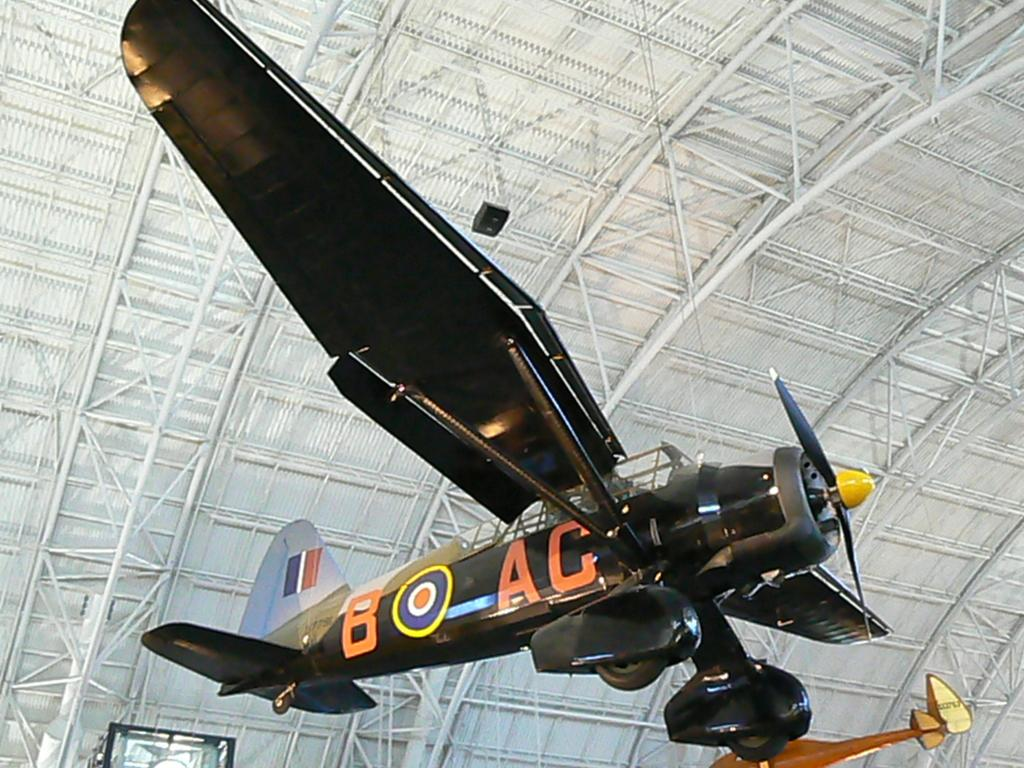<image>
Relay a brief, clear account of the picture shown. a plane with the words B AC are written on the side 